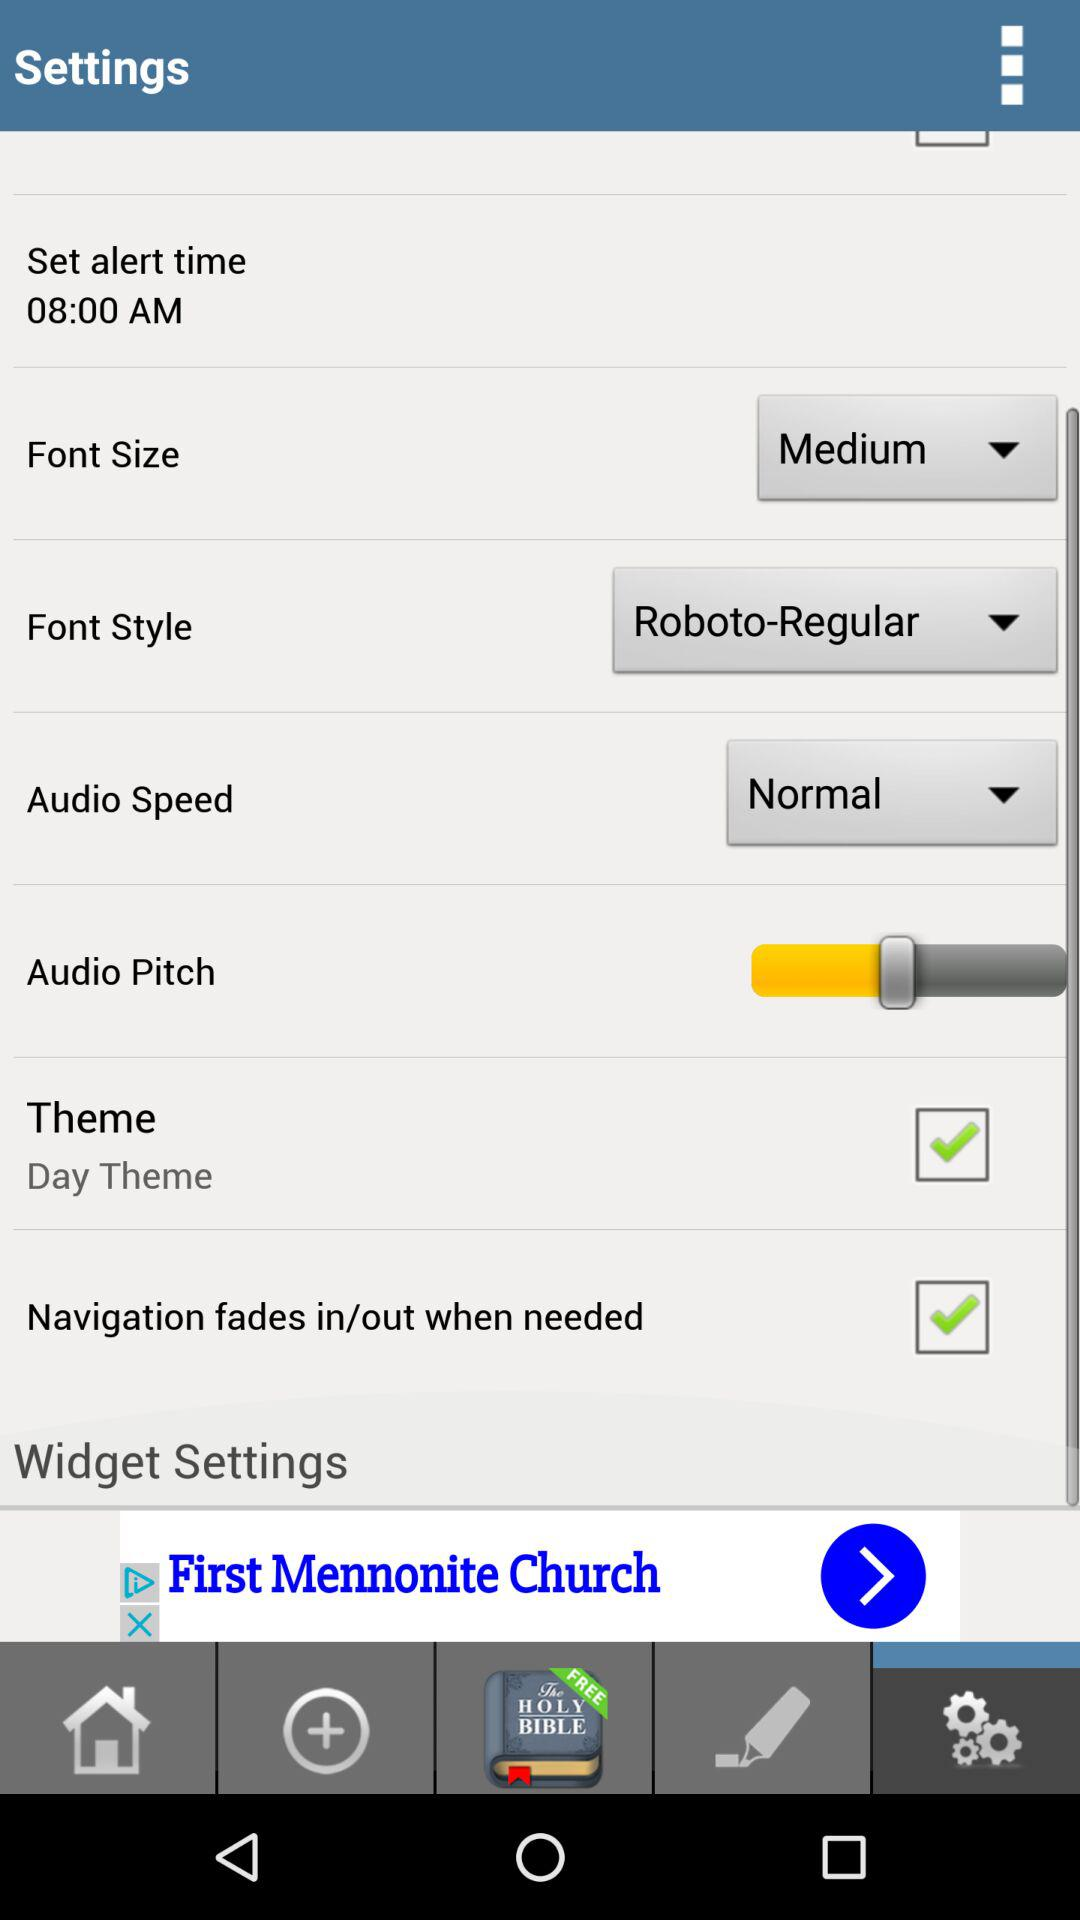What is the current status of the "Theme"? The status is "on". 